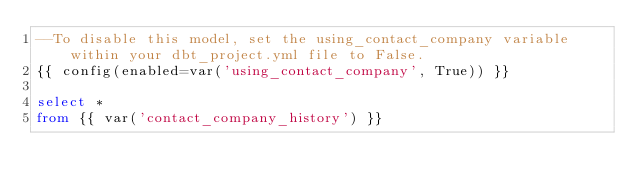<code> <loc_0><loc_0><loc_500><loc_500><_SQL_>--To disable this model, set the using_contact_company variable within your dbt_project.yml file to False.
{{ config(enabled=var('using_contact_company', True)) }}

select * 
from {{ var('contact_company_history') }}
</code> 